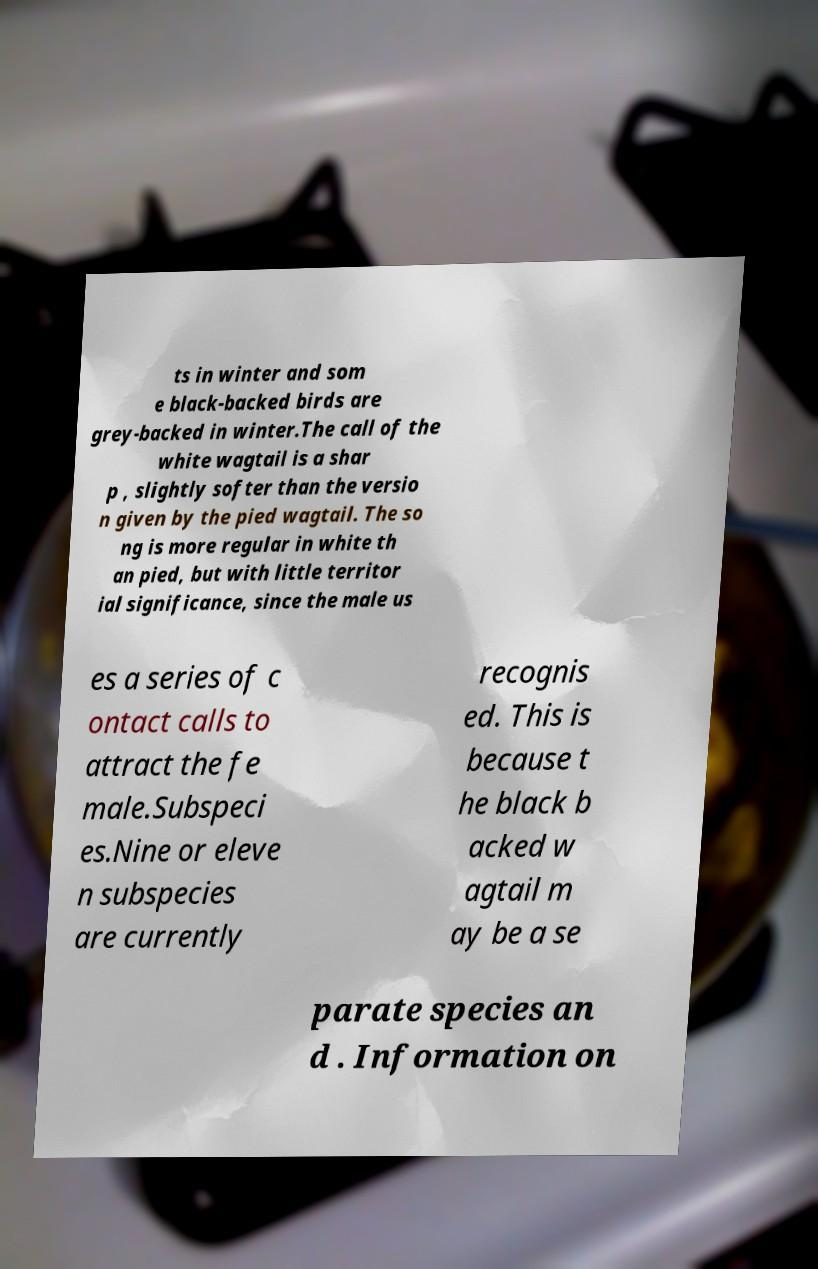There's text embedded in this image that I need extracted. Can you transcribe it verbatim? ts in winter and som e black-backed birds are grey-backed in winter.The call of the white wagtail is a shar p , slightly softer than the versio n given by the pied wagtail. The so ng is more regular in white th an pied, but with little territor ial significance, since the male us es a series of c ontact calls to attract the fe male.Subspeci es.Nine or eleve n subspecies are currently recognis ed. This is because t he black b acked w agtail m ay be a se parate species an d . Information on 